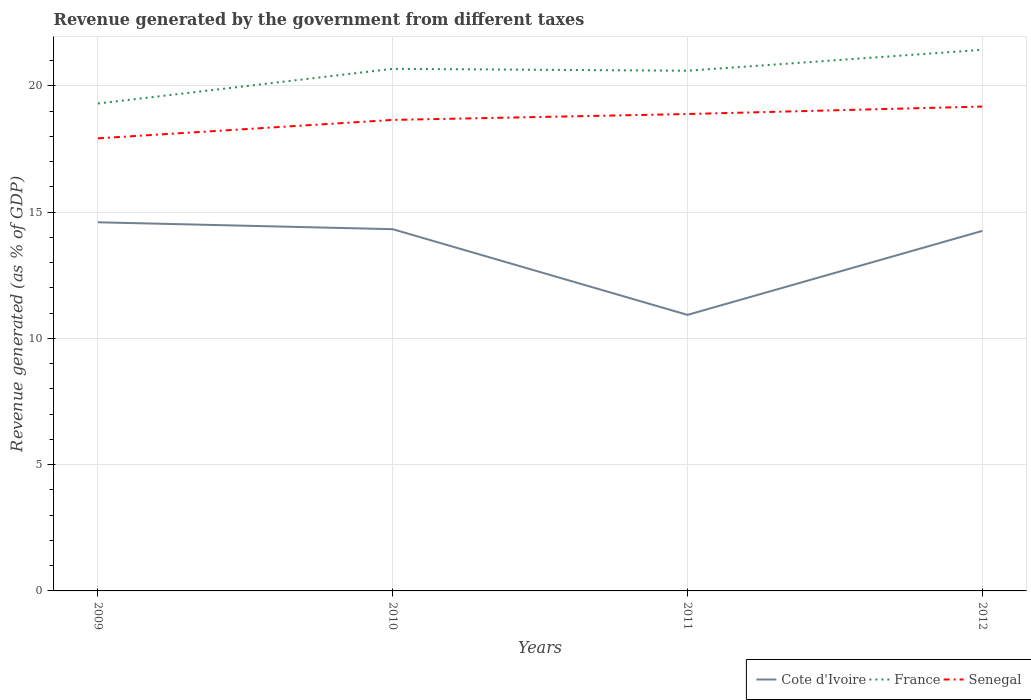How many different coloured lines are there?
Offer a terse response. 3. Does the line corresponding to Cote d'Ivoire intersect with the line corresponding to France?
Give a very brief answer. No. Across all years, what is the maximum revenue generated by the government in France?
Your answer should be very brief. 19.3. In which year was the revenue generated by the government in Cote d'Ivoire maximum?
Offer a very short reply. 2011. What is the total revenue generated by the government in Senegal in the graph?
Give a very brief answer. -0.23. What is the difference between the highest and the second highest revenue generated by the government in Senegal?
Give a very brief answer. 1.26. Is the revenue generated by the government in Senegal strictly greater than the revenue generated by the government in Cote d'Ivoire over the years?
Your response must be concise. No. How many lines are there?
Your response must be concise. 3. How many years are there in the graph?
Give a very brief answer. 4. What is the difference between two consecutive major ticks on the Y-axis?
Offer a very short reply. 5. Does the graph contain any zero values?
Your response must be concise. No. Does the graph contain grids?
Your response must be concise. Yes. Where does the legend appear in the graph?
Provide a succinct answer. Bottom right. How many legend labels are there?
Provide a short and direct response. 3. What is the title of the graph?
Give a very brief answer. Revenue generated by the government from different taxes. Does "Ukraine" appear as one of the legend labels in the graph?
Your answer should be very brief. No. What is the label or title of the X-axis?
Ensure brevity in your answer.  Years. What is the label or title of the Y-axis?
Your response must be concise. Revenue generated (as % of GDP). What is the Revenue generated (as % of GDP) of Cote d'Ivoire in 2009?
Provide a short and direct response. 14.6. What is the Revenue generated (as % of GDP) in France in 2009?
Offer a very short reply. 19.3. What is the Revenue generated (as % of GDP) of Senegal in 2009?
Your answer should be compact. 17.92. What is the Revenue generated (as % of GDP) in Cote d'Ivoire in 2010?
Offer a very short reply. 14.33. What is the Revenue generated (as % of GDP) of France in 2010?
Your response must be concise. 20.68. What is the Revenue generated (as % of GDP) of Senegal in 2010?
Keep it short and to the point. 18.65. What is the Revenue generated (as % of GDP) in Cote d'Ivoire in 2011?
Your response must be concise. 10.93. What is the Revenue generated (as % of GDP) of France in 2011?
Make the answer very short. 20.6. What is the Revenue generated (as % of GDP) in Senegal in 2011?
Your answer should be compact. 18.89. What is the Revenue generated (as % of GDP) of Cote d'Ivoire in 2012?
Give a very brief answer. 14.26. What is the Revenue generated (as % of GDP) in France in 2012?
Offer a very short reply. 21.43. What is the Revenue generated (as % of GDP) of Senegal in 2012?
Provide a succinct answer. 19.18. Across all years, what is the maximum Revenue generated (as % of GDP) in Cote d'Ivoire?
Provide a succinct answer. 14.6. Across all years, what is the maximum Revenue generated (as % of GDP) in France?
Give a very brief answer. 21.43. Across all years, what is the maximum Revenue generated (as % of GDP) of Senegal?
Offer a very short reply. 19.18. Across all years, what is the minimum Revenue generated (as % of GDP) of Cote d'Ivoire?
Provide a succinct answer. 10.93. Across all years, what is the minimum Revenue generated (as % of GDP) in France?
Your response must be concise. 19.3. Across all years, what is the minimum Revenue generated (as % of GDP) in Senegal?
Provide a succinct answer. 17.92. What is the total Revenue generated (as % of GDP) of Cote d'Ivoire in the graph?
Offer a terse response. 54.11. What is the total Revenue generated (as % of GDP) in France in the graph?
Provide a short and direct response. 82.01. What is the total Revenue generated (as % of GDP) of Senegal in the graph?
Offer a terse response. 74.64. What is the difference between the Revenue generated (as % of GDP) of Cote d'Ivoire in 2009 and that in 2010?
Your answer should be very brief. 0.27. What is the difference between the Revenue generated (as % of GDP) of France in 2009 and that in 2010?
Provide a succinct answer. -1.37. What is the difference between the Revenue generated (as % of GDP) in Senegal in 2009 and that in 2010?
Make the answer very short. -0.73. What is the difference between the Revenue generated (as % of GDP) of Cote d'Ivoire in 2009 and that in 2011?
Ensure brevity in your answer.  3.67. What is the difference between the Revenue generated (as % of GDP) in France in 2009 and that in 2011?
Your response must be concise. -1.3. What is the difference between the Revenue generated (as % of GDP) of Senegal in 2009 and that in 2011?
Make the answer very short. -0.96. What is the difference between the Revenue generated (as % of GDP) of Cote d'Ivoire in 2009 and that in 2012?
Keep it short and to the point. 0.34. What is the difference between the Revenue generated (as % of GDP) of France in 2009 and that in 2012?
Keep it short and to the point. -2.13. What is the difference between the Revenue generated (as % of GDP) of Senegal in 2009 and that in 2012?
Keep it short and to the point. -1.26. What is the difference between the Revenue generated (as % of GDP) of Cote d'Ivoire in 2010 and that in 2011?
Ensure brevity in your answer.  3.39. What is the difference between the Revenue generated (as % of GDP) in France in 2010 and that in 2011?
Provide a succinct answer. 0.07. What is the difference between the Revenue generated (as % of GDP) in Senegal in 2010 and that in 2011?
Provide a short and direct response. -0.23. What is the difference between the Revenue generated (as % of GDP) of Cote d'Ivoire in 2010 and that in 2012?
Provide a succinct answer. 0.07. What is the difference between the Revenue generated (as % of GDP) in France in 2010 and that in 2012?
Your answer should be compact. -0.75. What is the difference between the Revenue generated (as % of GDP) in Senegal in 2010 and that in 2012?
Keep it short and to the point. -0.53. What is the difference between the Revenue generated (as % of GDP) in Cote d'Ivoire in 2011 and that in 2012?
Provide a short and direct response. -3.33. What is the difference between the Revenue generated (as % of GDP) in France in 2011 and that in 2012?
Keep it short and to the point. -0.83. What is the difference between the Revenue generated (as % of GDP) in Senegal in 2011 and that in 2012?
Your response must be concise. -0.3. What is the difference between the Revenue generated (as % of GDP) of Cote d'Ivoire in 2009 and the Revenue generated (as % of GDP) of France in 2010?
Your answer should be very brief. -6.08. What is the difference between the Revenue generated (as % of GDP) of Cote d'Ivoire in 2009 and the Revenue generated (as % of GDP) of Senegal in 2010?
Ensure brevity in your answer.  -4.05. What is the difference between the Revenue generated (as % of GDP) of France in 2009 and the Revenue generated (as % of GDP) of Senegal in 2010?
Offer a terse response. 0.65. What is the difference between the Revenue generated (as % of GDP) of Cote d'Ivoire in 2009 and the Revenue generated (as % of GDP) of France in 2011?
Your answer should be compact. -6. What is the difference between the Revenue generated (as % of GDP) in Cote d'Ivoire in 2009 and the Revenue generated (as % of GDP) in Senegal in 2011?
Offer a very short reply. -4.29. What is the difference between the Revenue generated (as % of GDP) in France in 2009 and the Revenue generated (as % of GDP) in Senegal in 2011?
Make the answer very short. 0.42. What is the difference between the Revenue generated (as % of GDP) of Cote d'Ivoire in 2009 and the Revenue generated (as % of GDP) of France in 2012?
Offer a terse response. -6.83. What is the difference between the Revenue generated (as % of GDP) in Cote d'Ivoire in 2009 and the Revenue generated (as % of GDP) in Senegal in 2012?
Your answer should be compact. -4.58. What is the difference between the Revenue generated (as % of GDP) of France in 2009 and the Revenue generated (as % of GDP) of Senegal in 2012?
Provide a short and direct response. 0.12. What is the difference between the Revenue generated (as % of GDP) of Cote d'Ivoire in 2010 and the Revenue generated (as % of GDP) of France in 2011?
Your response must be concise. -6.28. What is the difference between the Revenue generated (as % of GDP) in Cote d'Ivoire in 2010 and the Revenue generated (as % of GDP) in Senegal in 2011?
Your answer should be compact. -4.56. What is the difference between the Revenue generated (as % of GDP) of France in 2010 and the Revenue generated (as % of GDP) of Senegal in 2011?
Provide a succinct answer. 1.79. What is the difference between the Revenue generated (as % of GDP) in Cote d'Ivoire in 2010 and the Revenue generated (as % of GDP) in France in 2012?
Ensure brevity in your answer.  -7.1. What is the difference between the Revenue generated (as % of GDP) of Cote d'Ivoire in 2010 and the Revenue generated (as % of GDP) of Senegal in 2012?
Make the answer very short. -4.86. What is the difference between the Revenue generated (as % of GDP) of France in 2010 and the Revenue generated (as % of GDP) of Senegal in 2012?
Ensure brevity in your answer.  1.49. What is the difference between the Revenue generated (as % of GDP) in Cote d'Ivoire in 2011 and the Revenue generated (as % of GDP) in France in 2012?
Keep it short and to the point. -10.5. What is the difference between the Revenue generated (as % of GDP) of Cote d'Ivoire in 2011 and the Revenue generated (as % of GDP) of Senegal in 2012?
Give a very brief answer. -8.25. What is the difference between the Revenue generated (as % of GDP) of France in 2011 and the Revenue generated (as % of GDP) of Senegal in 2012?
Give a very brief answer. 1.42. What is the average Revenue generated (as % of GDP) of Cote d'Ivoire per year?
Give a very brief answer. 13.53. What is the average Revenue generated (as % of GDP) of France per year?
Ensure brevity in your answer.  20.5. What is the average Revenue generated (as % of GDP) of Senegal per year?
Offer a very short reply. 18.66. In the year 2009, what is the difference between the Revenue generated (as % of GDP) in Cote d'Ivoire and Revenue generated (as % of GDP) in France?
Your response must be concise. -4.7. In the year 2009, what is the difference between the Revenue generated (as % of GDP) of Cote d'Ivoire and Revenue generated (as % of GDP) of Senegal?
Your answer should be compact. -3.32. In the year 2009, what is the difference between the Revenue generated (as % of GDP) in France and Revenue generated (as % of GDP) in Senegal?
Keep it short and to the point. 1.38. In the year 2010, what is the difference between the Revenue generated (as % of GDP) of Cote d'Ivoire and Revenue generated (as % of GDP) of France?
Provide a short and direct response. -6.35. In the year 2010, what is the difference between the Revenue generated (as % of GDP) of Cote d'Ivoire and Revenue generated (as % of GDP) of Senegal?
Offer a very short reply. -4.33. In the year 2010, what is the difference between the Revenue generated (as % of GDP) in France and Revenue generated (as % of GDP) in Senegal?
Ensure brevity in your answer.  2.02. In the year 2011, what is the difference between the Revenue generated (as % of GDP) in Cote d'Ivoire and Revenue generated (as % of GDP) in France?
Provide a succinct answer. -9.67. In the year 2011, what is the difference between the Revenue generated (as % of GDP) of Cote d'Ivoire and Revenue generated (as % of GDP) of Senegal?
Ensure brevity in your answer.  -7.95. In the year 2011, what is the difference between the Revenue generated (as % of GDP) of France and Revenue generated (as % of GDP) of Senegal?
Your answer should be very brief. 1.71. In the year 2012, what is the difference between the Revenue generated (as % of GDP) of Cote d'Ivoire and Revenue generated (as % of GDP) of France?
Offer a terse response. -7.17. In the year 2012, what is the difference between the Revenue generated (as % of GDP) of Cote d'Ivoire and Revenue generated (as % of GDP) of Senegal?
Your answer should be compact. -4.92. In the year 2012, what is the difference between the Revenue generated (as % of GDP) of France and Revenue generated (as % of GDP) of Senegal?
Make the answer very short. 2.25. What is the ratio of the Revenue generated (as % of GDP) of Cote d'Ivoire in 2009 to that in 2010?
Keep it short and to the point. 1.02. What is the ratio of the Revenue generated (as % of GDP) in France in 2009 to that in 2010?
Your response must be concise. 0.93. What is the ratio of the Revenue generated (as % of GDP) of Senegal in 2009 to that in 2010?
Keep it short and to the point. 0.96. What is the ratio of the Revenue generated (as % of GDP) of Cote d'Ivoire in 2009 to that in 2011?
Make the answer very short. 1.34. What is the ratio of the Revenue generated (as % of GDP) of France in 2009 to that in 2011?
Ensure brevity in your answer.  0.94. What is the ratio of the Revenue generated (as % of GDP) in Senegal in 2009 to that in 2011?
Your answer should be compact. 0.95. What is the ratio of the Revenue generated (as % of GDP) in France in 2009 to that in 2012?
Ensure brevity in your answer.  0.9. What is the ratio of the Revenue generated (as % of GDP) in Senegal in 2009 to that in 2012?
Your response must be concise. 0.93. What is the ratio of the Revenue generated (as % of GDP) of Cote d'Ivoire in 2010 to that in 2011?
Ensure brevity in your answer.  1.31. What is the ratio of the Revenue generated (as % of GDP) in France in 2010 to that in 2011?
Make the answer very short. 1. What is the ratio of the Revenue generated (as % of GDP) in Senegal in 2010 to that in 2011?
Offer a very short reply. 0.99. What is the ratio of the Revenue generated (as % of GDP) in France in 2010 to that in 2012?
Offer a very short reply. 0.96. What is the ratio of the Revenue generated (as % of GDP) in Senegal in 2010 to that in 2012?
Make the answer very short. 0.97. What is the ratio of the Revenue generated (as % of GDP) of Cote d'Ivoire in 2011 to that in 2012?
Provide a succinct answer. 0.77. What is the ratio of the Revenue generated (as % of GDP) of France in 2011 to that in 2012?
Your answer should be compact. 0.96. What is the ratio of the Revenue generated (as % of GDP) of Senegal in 2011 to that in 2012?
Make the answer very short. 0.98. What is the difference between the highest and the second highest Revenue generated (as % of GDP) of Cote d'Ivoire?
Your answer should be very brief. 0.27. What is the difference between the highest and the second highest Revenue generated (as % of GDP) of France?
Keep it short and to the point. 0.75. What is the difference between the highest and the second highest Revenue generated (as % of GDP) of Senegal?
Ensure brevity in your answer.  0.3. What is the difference between the highest and the lowest Revenue generated (as % of GDP) of Cote d'Ivoire?
Offer a very short reply. 3.67. What is the difference between the highest and the lowest Revenue generated (as % of GDP) of France?
Keep it short and to the point. 2.13. What is the difference between the highest and the lowest Revenue generated (as % of GDP) in Senegal?
Give a very brief answer. 1.26. 